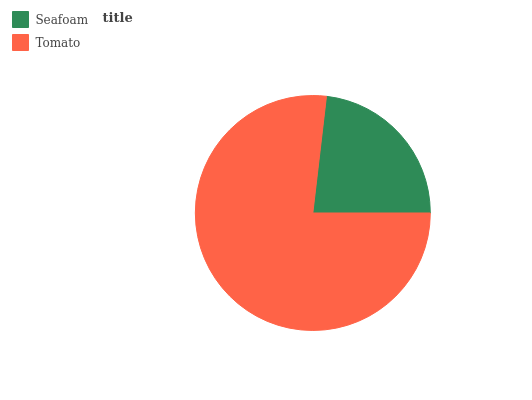Is Seafoam the minimum?
Answer yes or no. Yes. Is Tomato the maximum?
Answer yes or no. Yes. Is Tomato the minimum?
Answer yes or no. No. Is Tomato greater than Seafoam?
Answer yes or no. Yes. Is Seafoam less than Tomato?
Answer yes or no. Yes. Is Seafoam greater than Tomato?
Answer yes or no. No. Is Tomato less than Seafoam?
Answer yes or no. No. Is Tomato the high median?
Answer yes or no. Yes. Is Seafoam the low median?
Answer yes or no. Yes. Is Seafoam the high median?
Answer yes or no. No. Is Tomato the low median?
Answer yes or no. No. 